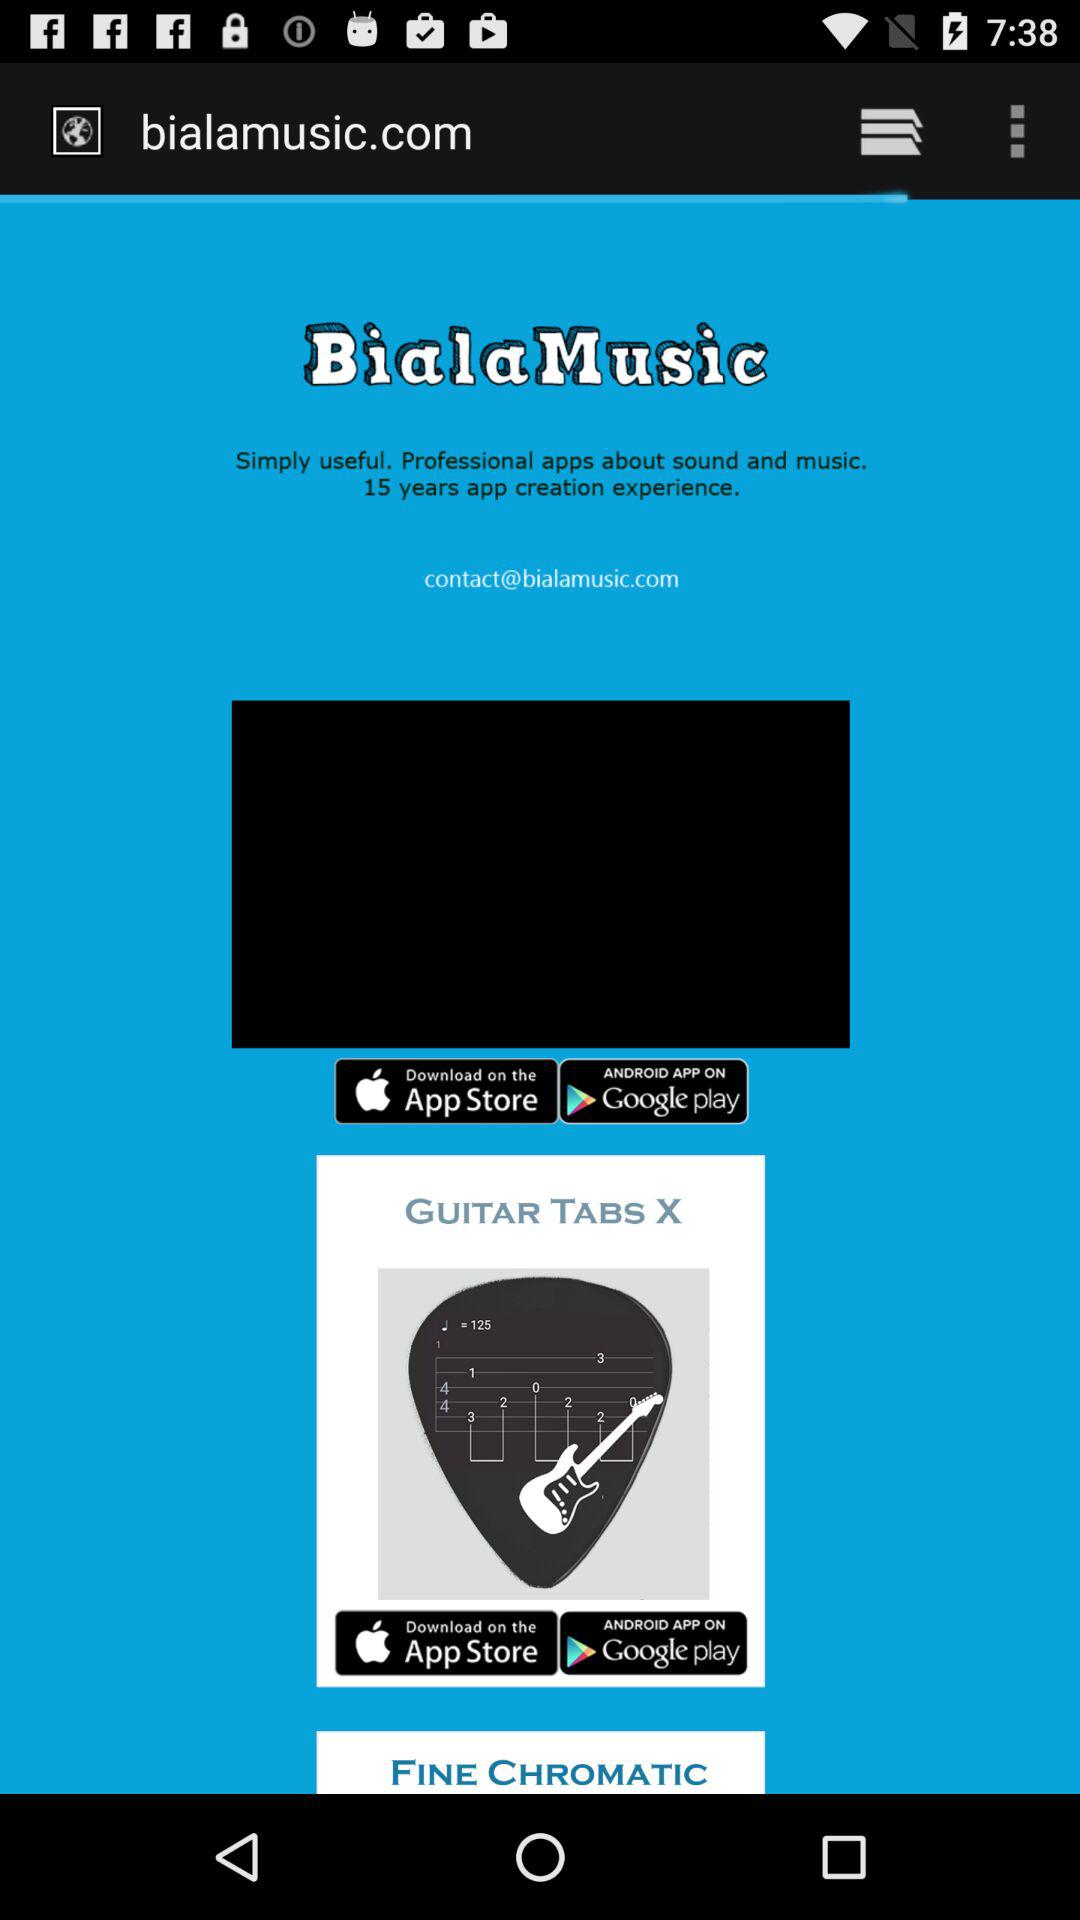What is the application name? The application name is "GUITAR TABS X". 